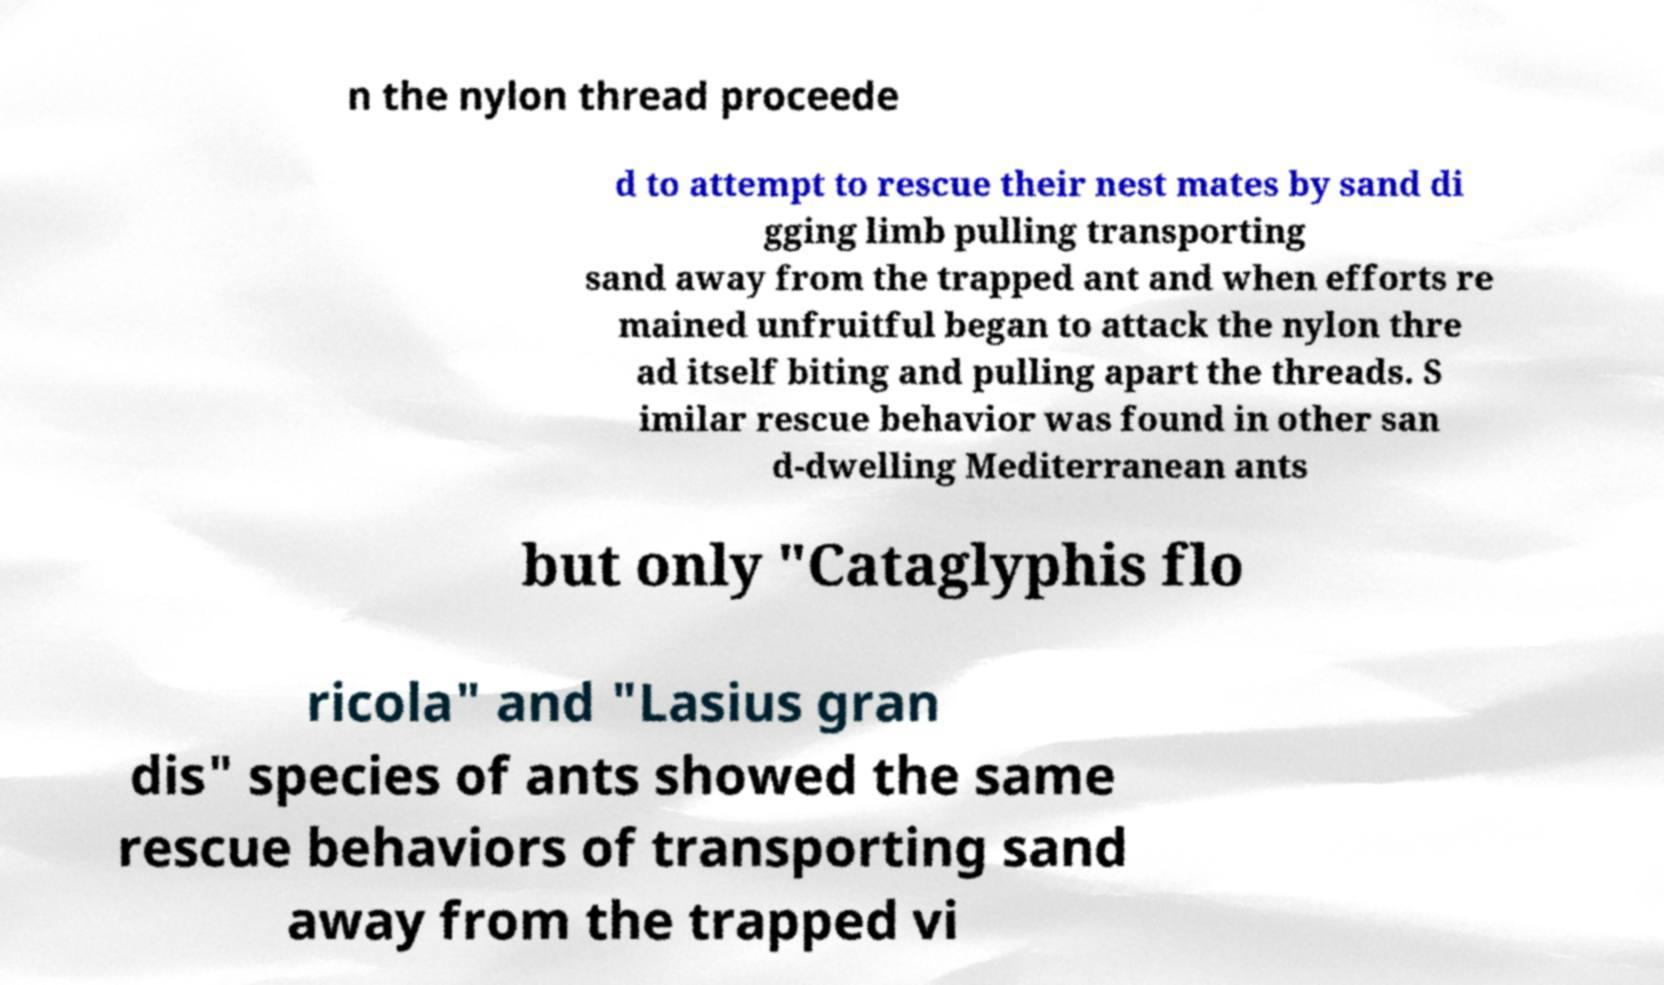There's text embedded in this image that I need extracted. Can you transcribe it verbatim? n the nylon thread proceede d to attempt to rescue their nest mates by sand di gging limb pulling transporting sand away from the trapped ant and when efforts re mained unfruitful began to attack the nylon thre ad itself biting and pulling apart the threads. S imilar rescue behavior was found in other san d-dwelling Mediterranean ants but only "Cataglyphis flo ricola" and "Lasius gran dis" species of ants showed the same rescue behaviors of transporting sand away from the trapped vi 